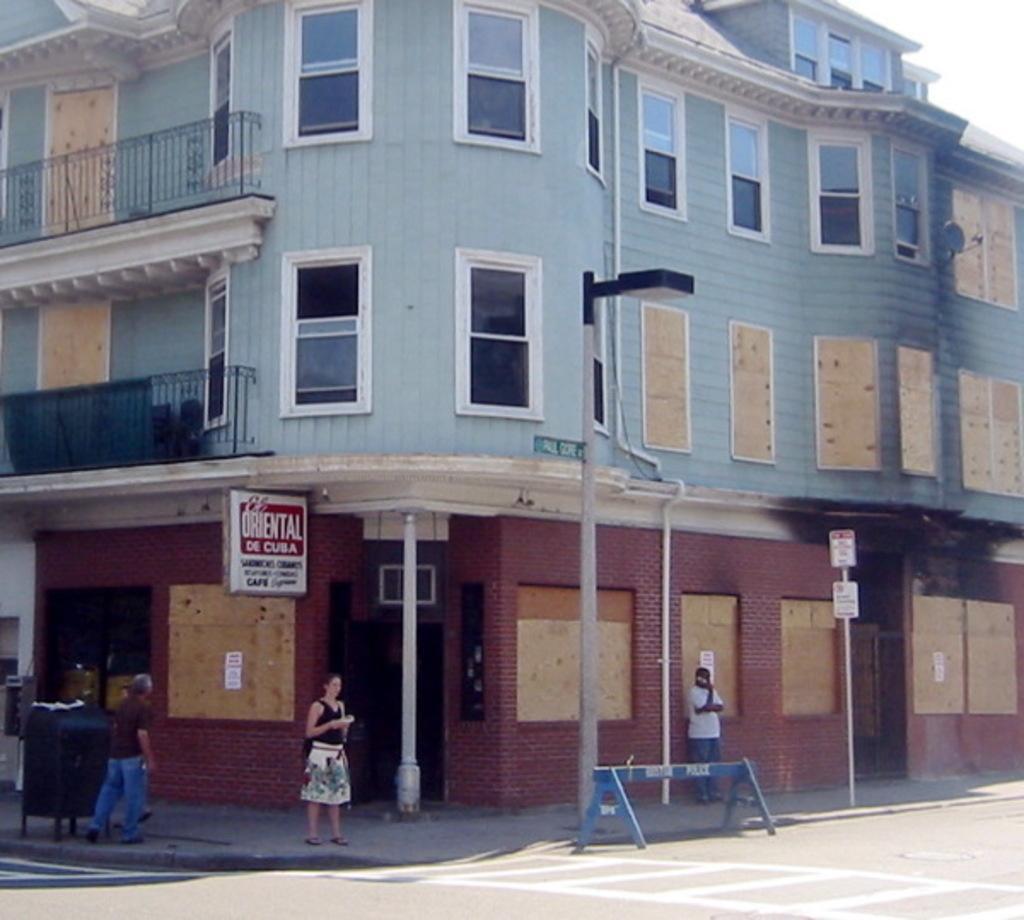In one or two sentences, can you explain what this image depicts? This is the picture of a building. In this image there are two persons standing on the footpath and there is a person walking on the footpath. There is a pole and dustbin on the footpath. At the back there is a building and there is a board on the building. At the top there is sky. At the bottom there is a road. 